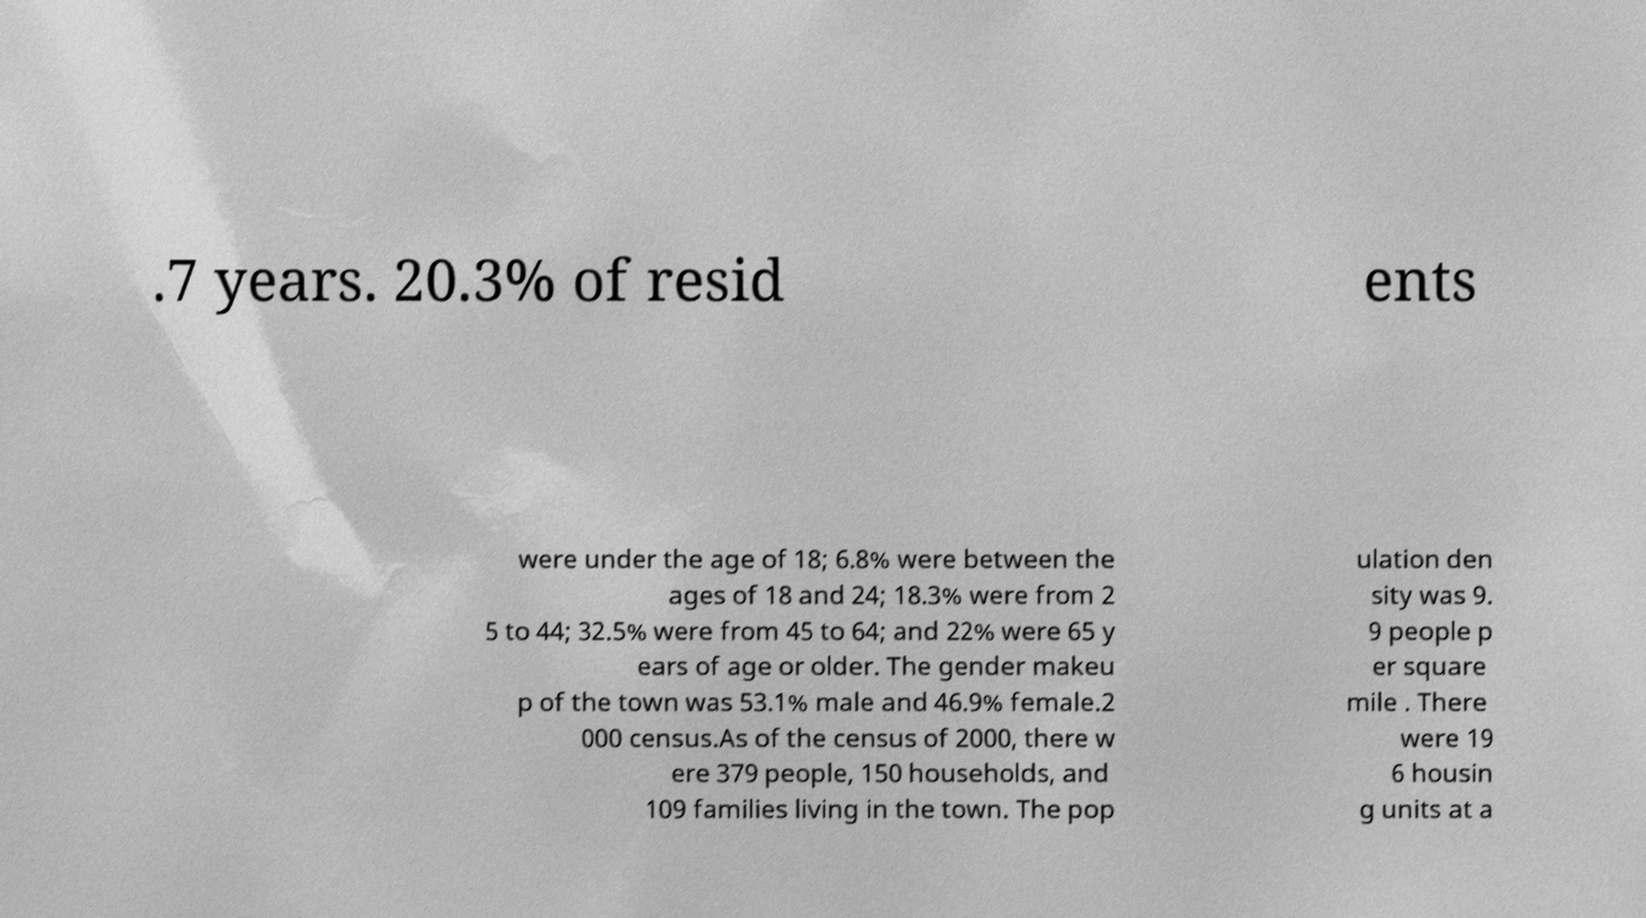Please identify and transcribe the text found in this image. .7 years. 20.3% of resid ents were under the age of 18; 6.8% were between the ages of 18 and 24; 18.3% were from 2 5 to 44; 32.5% were from 45 to 64; and 22% were 65 y ears of age or older. The gender makeu p of the town was 53.1% male and 46.9% female.2 000 census.As of the census of 2000, there w ere 379 people, 150 households, and 109 families living in the town. The pop ulation den sity was 9. 9 people p er square mile . There were 19 6 housin g units at a 